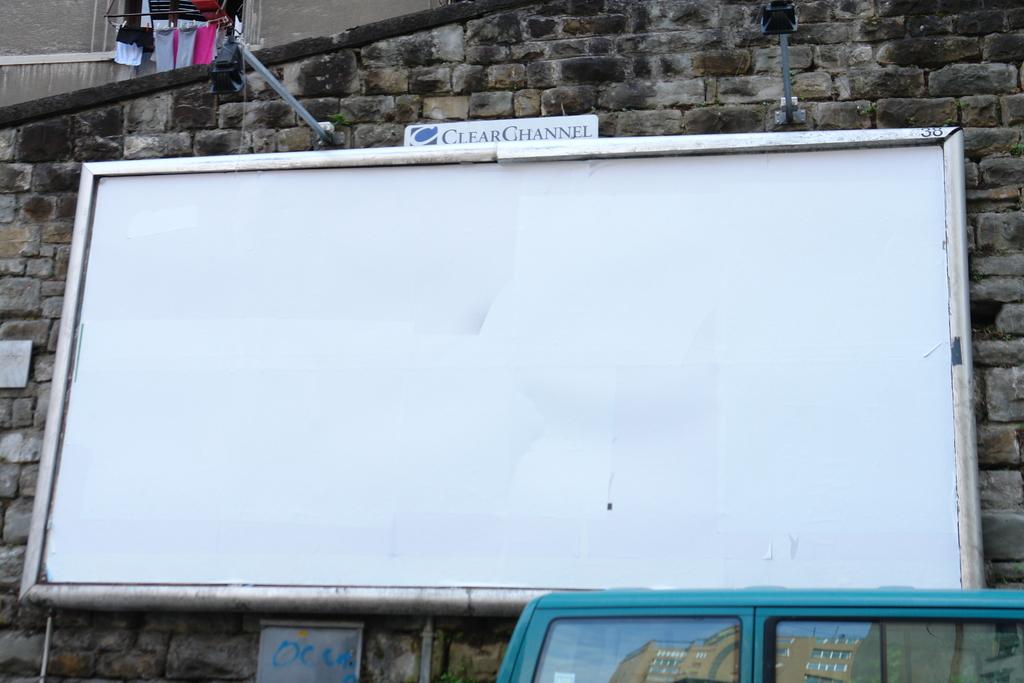What does the sign above the white board say?
Provide a short and direct response. Clear channel. 